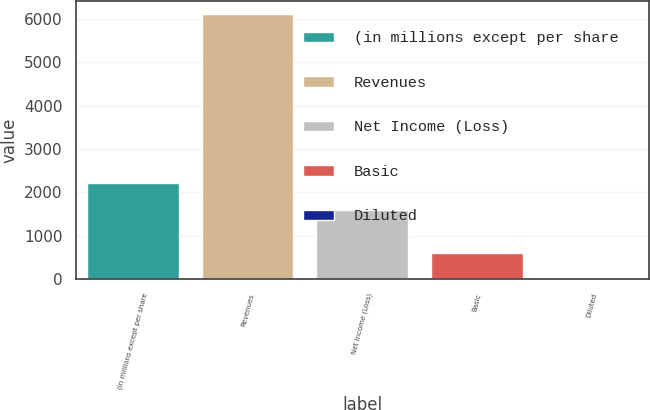<chart> <loc_0><loc_0><loc_500><loc_500><bar_chart><fcel>(in millions except per share<fcel>Revenues<fcel>Net Income (Loss)<fcel>Basic<fcel>Diluted<nl><fcel>2217.81<fcel>6112<fcel>1607<fcel>614.75<fcel>3.94<nl></chart> 